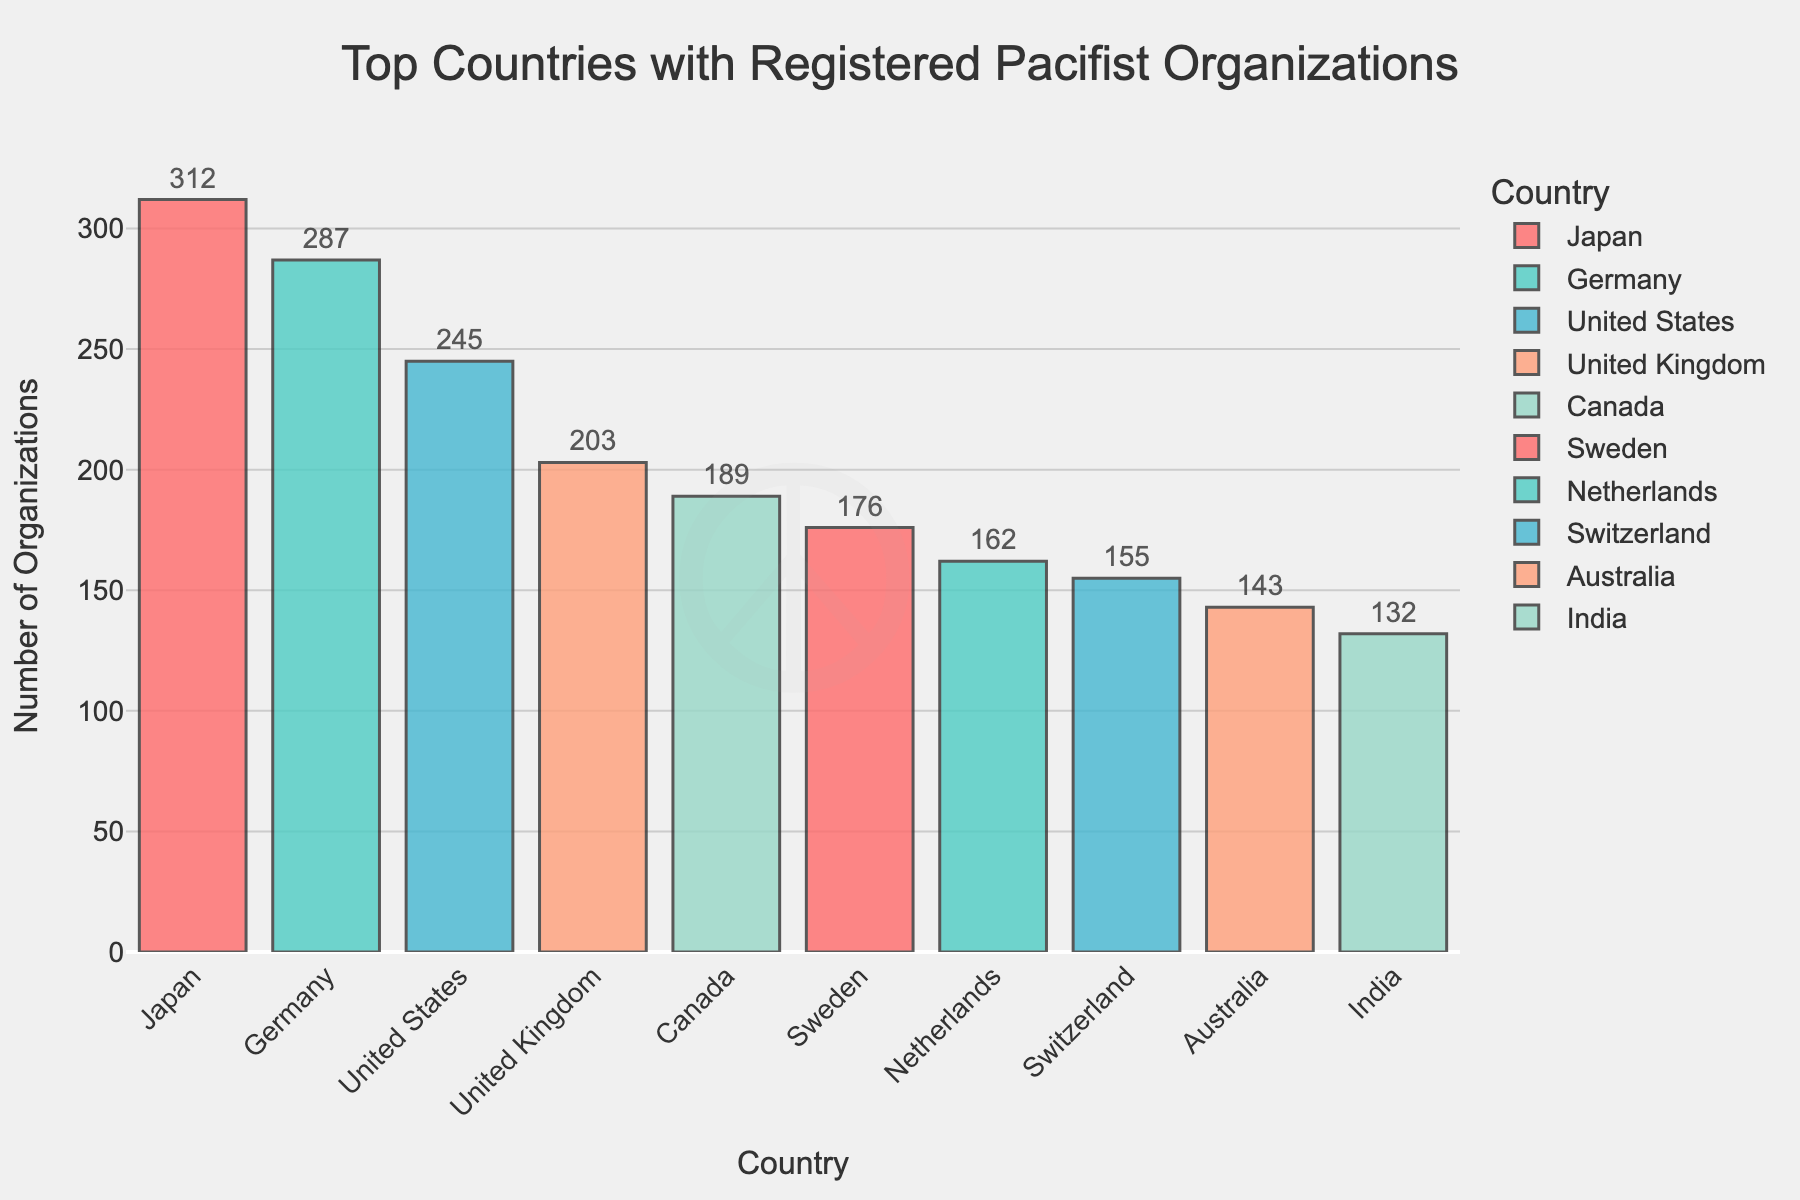Which country has the highest number of registered pacifist organizations? Japan has the highest bar in the chart, which indicates it has the most registered pacifist organizations.
Answer: Japan Which country has the second-highest number of registered pacifist organizations? The second tallest bar in the chart represents Germany. Therefore, Germany has the second-highest number of registered pacifist organizations.
Answer: Germany What is the total number of registered pacifist organizations in the top three countries? Add the numbers from the top three countries: Japan (312), Germany (287), and the United States (245). The total is 312 + 287 + 245 = 844.
Answer: 844 By how many organizations does Japan have more than Canada? Subtract the number of organizations in Canada (189) from Japan's total (312): 312 - 189 = 123.
Answer: 123 Which country has fewer registered pacifist organizations, Canada or the United Kingdom? Compare the heights of the bars for Canada and the United Kingdom. The United Kingdom has 203 organizations, while Canada has 189. Canada has fewer than the United Kingdom.
Answer: Canada Which country represents the bar colored in red? From the custom color palette applied, the red bar corresponds to the first country, Japan.
Answer: Japan Is the number of registered pacifist organizations in Sweden more or less than in the Netherlands? Compare the bars representing Sweden and the Netherlands. The bar for Sweden (176) is taller than that for the Netherlands (162).
Answer: More What is the average number of registered pacifist organizations in the top five countries? Sum the numbers from Japan (312), Germany (287), the United States (245), the United Kingdom (203), and Canada (189), then divide by 5: (312 + 287 + 245 + 203 + 189) / 5 = 1236 / 5 = 247.2.
Answer: 247.2 How much larger is the number of registered pacifist organizations in Japan compared to Sweden? Subtract the number of organizations in Sweden (176) from Japan's total (312): 312 - 176 = 136.
Answer: 136 What is the difference in the number of registered pacifist organizations between Germany and the United States? Subtract the number of organizations in the United States (245) from Germany's total (287): 287 - 245 = 42.
Answer: 42 